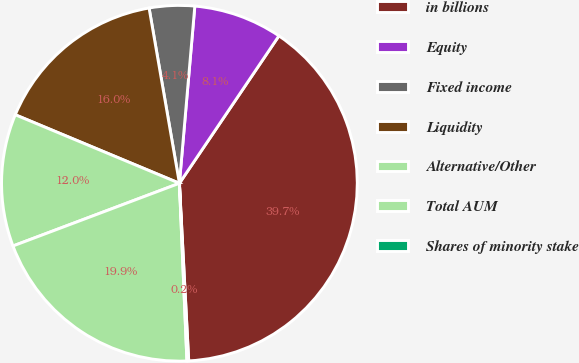<chart> <loc_0><loc_0><loc_500><loc_500><pie_chart><fcel>in billions<fcel>Equity<fcel>Fixed income<fcel>Liquidity<fcel>Alternative/Other<fcel>Total AUM<fcel>Shares of minority stake<nl><fcel>39.72%<fcel>8.07%<fcel>4.11%<fcel>15.98%<fcel>12.03%<fcel>19.94%<fcel>0.16%<nl></chart> 